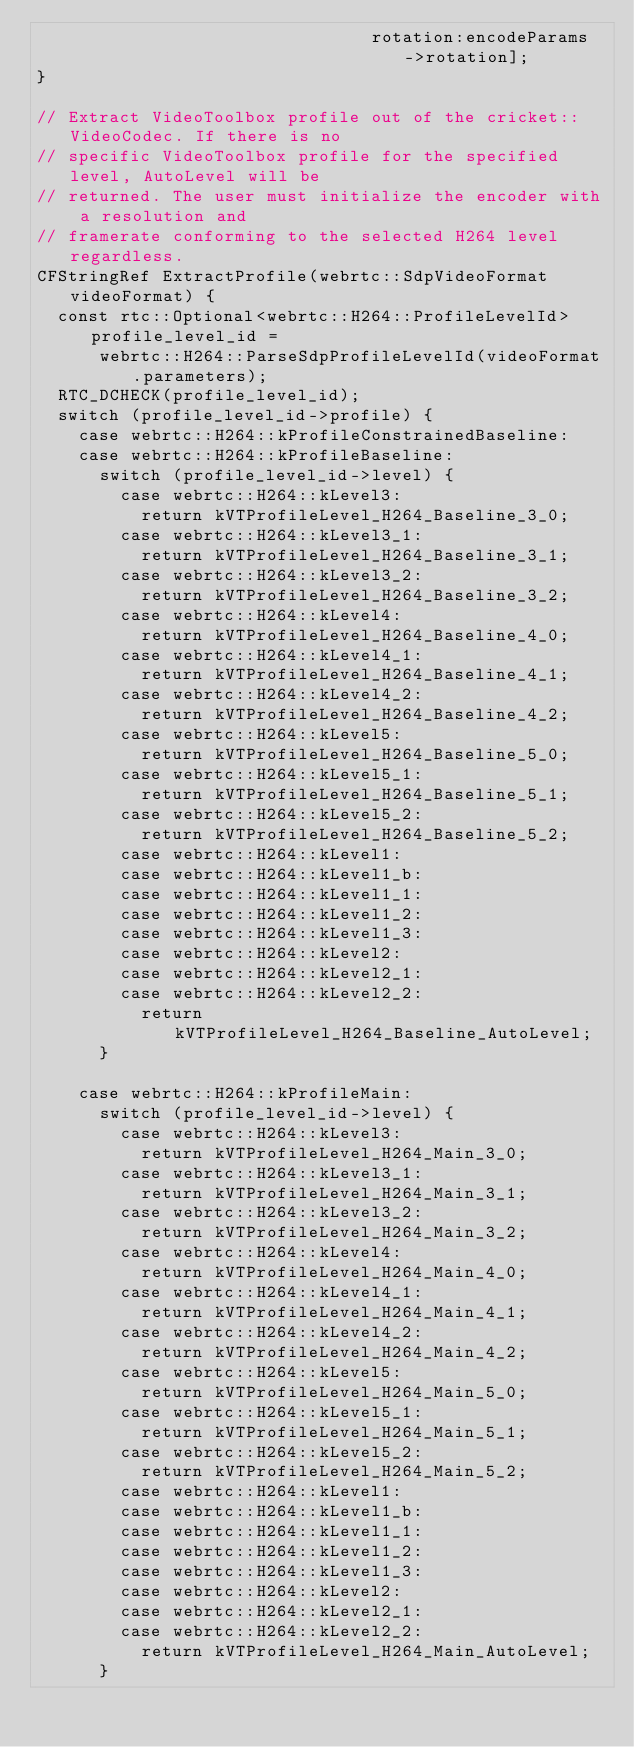<code> <loc_0><loc_0><loc_500><loc_500><_ObjectiveC_>                                rotation:encodeParams->rotation];
}

// Extract VideoToolbox profile out of the cricket::VideoCodec. If there is no
// specific VideoToolbox profile for the specified level, AutoLevel will be
// returned. The user must initialize the encoder with a resolution and
// framerate conforming to the selected H264 level regardless.
CFStringRef ExtractProfile(webrtc::SdpVideoFormat videoFormat) {
  const rtc::Optional<webrtc::H264::ProfileLevelId> profile_level_id =
      webrtc::H264::ParseSdpProfileLevelId(videoFormat.parameters);
  RTC_DCHECK(profile_level_id);
  switch (profile_level_id->profile) {
    case webrtc::H264::kProfileConstrainedBaseline:
    case webrtc::H264::kProfileBaseline:
      switch (profile_level_id->level) {
        case webrtc::H264::kLevel3:
          return kVTProfileLevel_H264_Baseline_3_0;
        case webrtc::H264::kLevel3_1:
          return kVTProfileLevel_H264_Baseline_3_1;
        case webrtc::H264::kLevel3_2:
          return kVTProfileLevel_H264_Baseline_3_2;
        case webrtc::H264::kLevel4:
          return kVTProfileLevel_H264_Baseline_4_0;
        case webrtc::H264::kLevel4_1:
          return kVTProfileLevel_H264_Baseline_4_1;
        case webrtc::H264::kLevel4_2:
          return kVTProfileLevel_H264_Baseline_4_2;
        case webrtc::H264::kLevel5:
          return kVTProfileLevel_H264_Baseline_5_0;
        case webrtc::H264::kLevel5_1:
          return kVTProfileLevel_H264_Baseline_5_1;
        case webrtc::H264::kLevel5_2:
          return kVTProfileLevel_H264_Baseline_5_2;
        case webrtc::H264::kLevel1:
        case webrtc::H264::kLevel1_b:
        case webrtc::H264::kLevel1_1:
        case webrtc::H264::kLevel1_2:
        case webrtc::H264::kLevel1_3:
        case webrtc::H264::kLevel2:
        case webrtc::H264::kLevel2_1:
        case webrtc::H264::kLevel2_2:
          return kVTProfileLevel_H264_Baseline_AutoLevel;
      }

    case webrtc::H264::kProfileMain:
      switch (profile_level_id->level) {
        case webrtc::H264::kLevel3:
          return kVTProfileLevel_H264_Main_3_0;
        case webrtc::H264::kLevel3_1:
          return kVTProfileLevel_H264_Main_3_1;
        case webrtc::H264::kLevel3_2:
          return kVTProfileLevel_H264_Main_3_2;
        case webrtc::H264::kLevel4:
          return kVTProfileLevel_H264_Main_4_0;
        case webrtc::H264::kLevel4_1:
          return kVTProfileLevel_H264_Main_4_1;
        case webrtc::H264::kLevel4_2:
          return kVTProfileLevel_H264_Main_4_2;
        case webrtc::H264::kLevel5:
          return kVTProfileLevel_H264_Main_5_0;
        case webrtc::H264::kLevel5_1:
          return kVTProfileLevel_H264_Main_5_1;
        case webrtc::H264::kLevel5_2:
          return kVTProfileLevel_H264_Main_5_2;
        case webrtc::H264::kLevel1:
        case webrtc::H264::kLevel1_b:
        case webrtc::H264::kLevel1_1:
        case webrtc::H264::kLevel1_2:
        case webrtc::H264::kLevel1_3:
        case webrtc::H264::kLevel2:
        case webrtc::H264::kLevel2_1:
        case webrtc::H264::kLevel2_2:
          return kVTProfileLevel_H264_Main_AutoLevel;
      }
</code> 